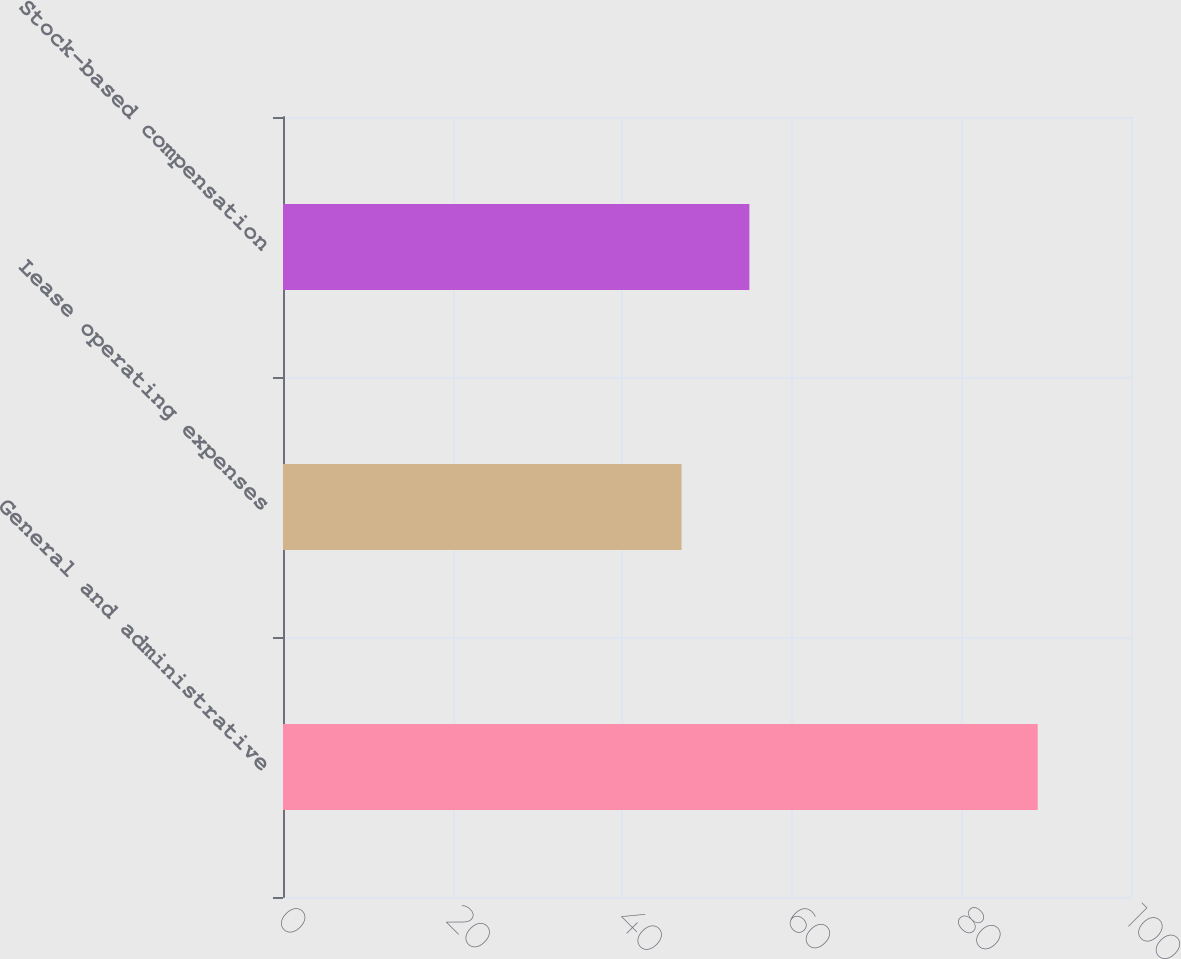<chart> <loc_0><loc_0><loc_500><loc_500><bar_chart><fcel>General and administrative<fcel>Lease operating expenses<fcel>Stock-based compensation<nl><fcel>89<fcel>47<fcel>55<nl></chart> 